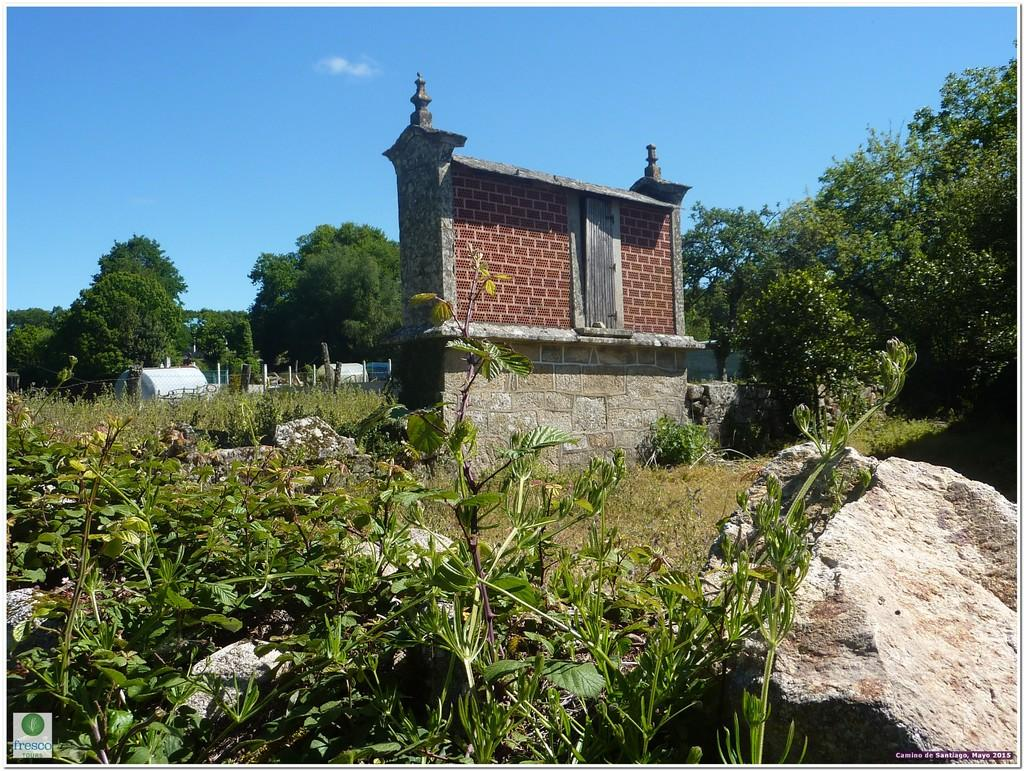What can be seen in the center of the image? The center of the image contains the sky, clouds, trees, plants, grass, stones, poles, and tents. How many buildings are present in the image? There is one building in the image. Where is the logo located in the image? The logo is in the bottom left side of the image. What type of wealth is being mined in the image? There is no mine or indication of wealth mining in the image. 